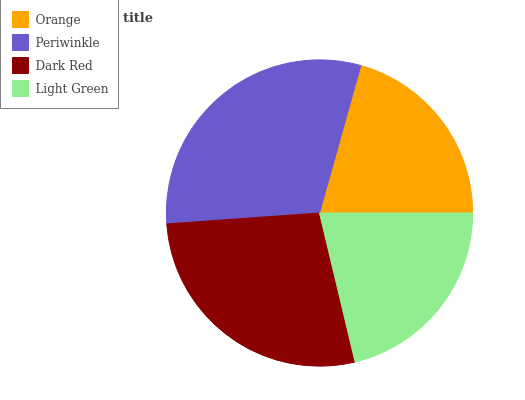Is Orange the minimum?
Answer yes or no. Yes. Is Periwinkle the maximum?
Answer yes or no. Yes. Is Dark Red the minimum?
Answer yes or no. No. Is Dark Red the maximum?
Answer yes or no. No. Is Periwinkle greater than Dark Red?
Answer yes or no. Yes. Is Dark Red less than Periwinkle?
Answer yes or no. Yes. Is Dark Red greater than Periwinkle?
Answer yes or no. No. Is Periwinkle less than Dark Red?
Answer yes or no. No. Is Dark Red the high median?
Answer yes or no. Yes. Is Light Green the low median?
Answer yes or no. Yes. Is Light Green the high median?
Answer yes or no. No. Is Dark Red the low median?
Answer yes or no. No. 